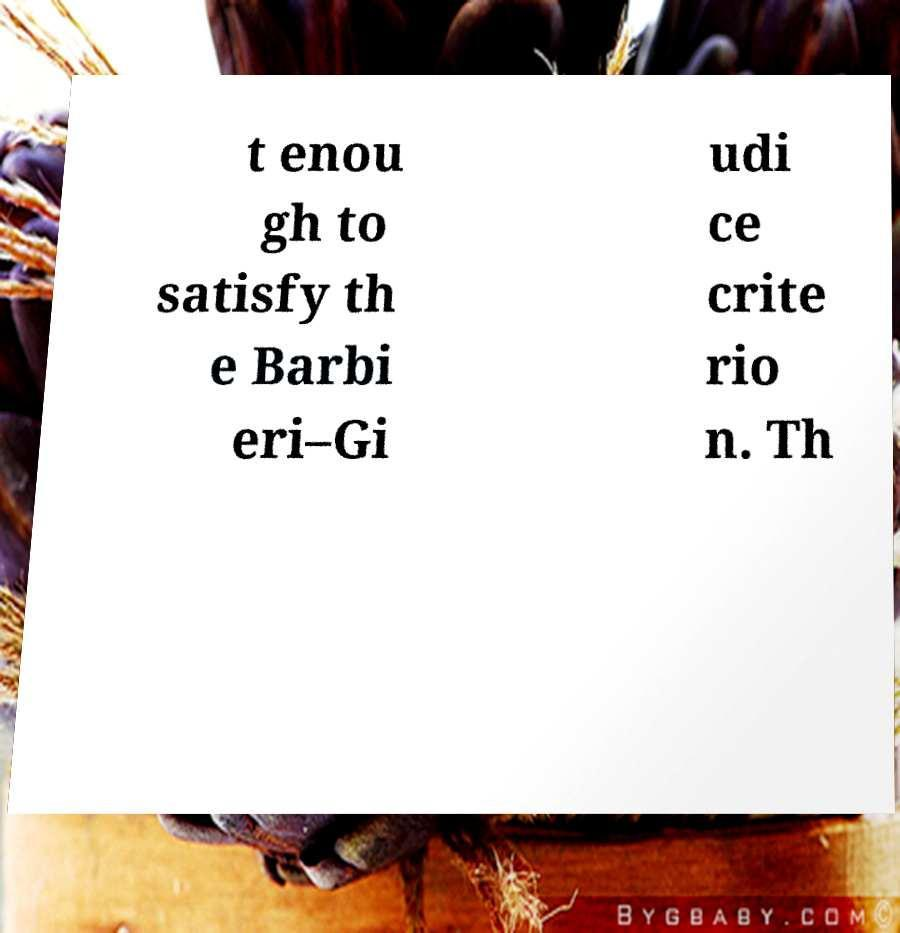Can you accurately transcribe the text from the provided image for me? t enou gh to satisfy th e Barbi eri–Gi udi ce crite rio n. Th 